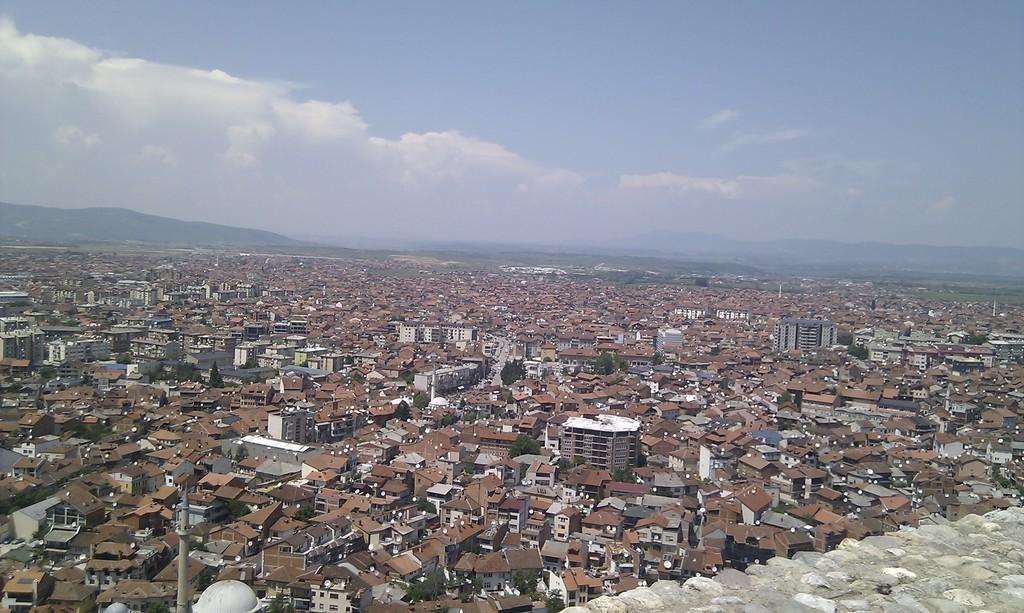Can you describe this image briefly? This picture is clicked outside the city. In the center we can see many number of buildings and houses. In the background there is a sky which is full of clouds and we can see the hills. 